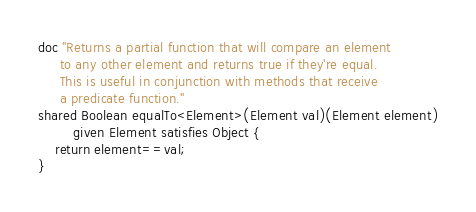Convert code to text. <code><loc_0><loc_0><loc_500><loc_500><_Ceylon_>doc "Returns a partial function that will compare an element
     to any other element and returns true if they're equal.
     This is useful in conjunction with methods that receive
     a predicate function."
shared Boolean equalTo<Element>(Element val)(Element element)
        given Element satisfies Object {
    return element==val;
}
</code> 